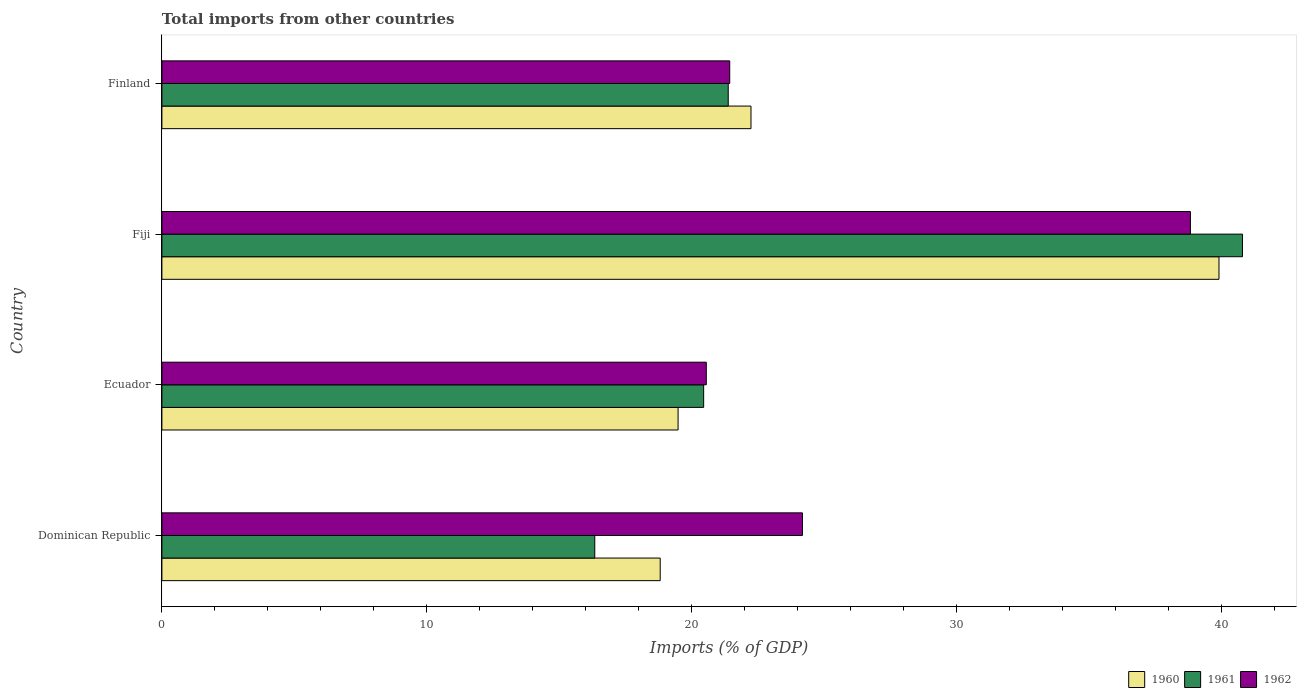How many different coloured bars are there?
Offer a very short reply. 3. How many bars are there on the 2nd tick from the top?
Your answer should be very brief. 3. What is the label of the 2nd group of bars from the top?
Your answer should be compact. Fiji. In how many cases, is the number of bars for a given country not equal to the number of legend labels?
Keep it short and to the point. 0. What is the total imports in 1961 in Ecuador?
Keep it short and to the point. 20.45. Across all countries, what is the maximum total imports in 1960?
Your answer should be very brief. 39.91. Across all countries, what is the minimum total imports in 1961?
Offer a very short reply. 16.34. In which country was the total imports in 1962 maximum?
Your answer should be compact. Fiji. In which country was the total imports in 1962 minimum?
Give a very brief answer. Ecuador. What is the total total imports in 1961 in the graph?
Provide a succinct answer. 98.98. What is the difference between the total imports in 1962 in Dominican Republic and that in Ecuador?
Offer a very short reply. 3.63. What is the difference between the total imports in 1962 in Finland and the total imports in 1961 in Dominican Republic?
Keep it short and to the point. 5.09. What is the average total imports in 1962 per country?
Your answer should be very brief. 26.25. What is the difference between the total imports in 1960 and total imports in 1962 in Fiji?
Your response must be concise. 1.08. In how many countries, is the total imports in 1961 greater than 8 %?
Provide a short and direct response. 4. What is the ratio of the total imports in 1961 in Ecuador to that in Finland?
Provide a succinct answer. 0.96. What is the difference between the highest and the second highest total imports in 1960?
Provide a short and direct response. 17.67. What is the difference between the highest and the lowest total imports in 1961?
Keep it short and to the point. 24.45. In how many countries, is the total imports in 1961 greater than the average total imports in 1961 taken over all countries?
Provide a succinct answer. 1. What does the 1st bar from the bottom in Ecuador represents?
Offer a terse response. 1960. Are the values on the major ticks of X-axis written in scientific E-notation?
Keep it short and to the point. No. Does the graph contain any zero values?
Make the answer very short. No. Does the graph contain grids?
Your answer should be compact. No. How many legend labels are there?
Offer a very short reply. 3. What is the title of the graph?
Keep it short and to the point. Total imports from other countries. Does "1960" appear as one of the legend labels in the graph?
Provide a short and direct response. Yes. What is the label or title of the X-axis?
Make the answer very short. Imports (% of GDP). What is the Imports (% of GDP) of 1960 in Dominican Republic?
Provide a short and direct response. 18.81. What is the Imports (% of GDP) of 1961 in Dominican Republic?
Offer a terse response. 16.34. What is the Imports (% of GDP) in 1962 in Dominican Republic?
Your answer should be very brief. 24.18. What is the Imports (% of GDP) of 1960 in Ecuador?
Provide a short and direct response. 19.49. What is the Imports (% of GDP) of 1961 in Ecuador?
Provide a succinct answer. 20.45. What is the Imports (% of GDP) in 1962 in Ecuador?
Provide a short and direct response. 20.55. What is the Imports (% of GDP) in 1960 in Fiji?
Offer a terse response. 39.91. What is the Imports (% of GDP) of 1961 in Fiji?
Provide a short and direct response. 40.8. What is the Imports (% of GDP) in 1962 in Fiji?
Provide a succinct answer. 38.83. What is the Imports (% of GDP) of 1960 in Finland?
Your response must be concise. 22.24. What is the Imports (% of GDP) of 1961 in Finland?
Keep it short and to the point. 21.38. What is the Imports (% of GDP) in 1962 in Finland?
Keep it short and to the point. 21.44. Across all countries, what is the maximum Imports (% of GDP) in 1960?
Offer a terse response. 39.91. Across all countries, what is the maximum Imports (% of GDP) of 1961?
Your answer should be compact. 40.8. Across all countries, what is the maximum Imports (% of GDP) of 1962?
Your response must be concise. 38.83. Across all countries, what is the minimum Imports (% of GDP) in 1960?
Ensure brevity in your answer.  18.81. Across all countries, what is the minimum Imports (% of GDP) in 1961?
Your answer should be compact. 16.34. Across all countries, what is the minimum Imports (% of GDP) in 1962?
Provide a succinct answer. 20.55. What is the total Imports (% of GDP) of 1960 in the graph?
Give a very brief answer. 100.45. What is the total Imports (% of GDP) of 1961 in the graph?
Ensure brevity in your answer.  98.98. What is the total Imports (% of GDP) in 1962 in the graph?
Offer a very short reply. 105.01. What is the difference between the Imports (% of GDP) of 1960 in Dominican Republic and that in Ecuador?
Give a very brief answer. -0.68. What is the difference between the Imports (% of GDP) of 1961 in Dominican Republic and that in Ecuador?
Your answer should be compact. -4.11. What is the difference between the Imports (% of GDP) in 1962 in Dominican Republic and that in Ecuador?
Ensure brevity in your answer.  3.63. What is the difference between the Imports (% of GDP) of 1960 in Dominican Republic and that in Fiji?
Offer a very short reply. -21.1. What is the difference between the Imports (% of GDP) of 1961 in Dominican Republic and that in Fiji?
Give a very brief answer. -24.45. What is the difference between the Imports (% of GDP) of 1962 in Dominican Republic and that in Fiji?
Your response must be concise. -14.65. What is the difference between the Imports (% of GDP) of 1960 in Dominican Republic and that in Finland?
Make the answer very short. -3.43. What is the difference between the Imports (% of GDP) of 1961 in Dominican Republic and that in Finland?
Your response must be concise. -5.04. What is the difference between the Imports (% of GDP) in 1962 in Dominican Republic and that in Finland?
Offer a terse response. 2.75. What is the difference between the Imports (% of GDP) of 1960 in Ecuador and that in Fiji?
Provide a succinct answer. -20.42. What is the difference between the Imports (% of GDP) of 1961 in Ecuador and that in Fiji?
Your answer should be very brief. -20.34. What is the difference between the Imports (% of GDP) of 1962 in Ecuador and that in Fiji?
Ensure brevity in your answer.  -18.28. What is the difference between the Imports (% of GDP) in 1960 in Ecuador and that in Finland?
Provide a succinct answer. -2.75. What is the difference between the Imports (% of GDP) of 1961 in Ecuador and that in Finland?
Provide a succinct answer. -0.93. What is the difference between the Imports (% of GDP) in 1962 in Ecuador and that in Finland?
Ensure brevity in your answer.  -0.88. What is the difference between the Imports (% of GDP) of 1960 in Fiji and that in Finland?
Your answer should be compact. 17.67. What is the difference between the Imports (% of GDP) of 1961 in Fiji and that in Finland?
Give a very brief answer. 19.41. What is the difference between the Imports (% of GDP) of 1962 in Fiji and that in Finland?
Give a very brief answer. 17.39. What is the difference between the Imports (% of GDP) of 1960 in Dominican Republic and the Imports (% of GDP) of 1961 in Ecuador?
Make the answer very short. -1.64. What is the difference between the Imports (% of GDP) in 1960 in Dominican Republic and the Imports (% of GDP) in 1962 in Ecuador?
Give a very brief answer. -1.74. What is the difference between the Imports (% of GDP) in 1961 in Dominican Republic and the Imports (% of GDP) in 1962 in Ecuador?
Offer a very short reply. -4.21. What is the difference between the Imports (% of GDP) of 1960 in Dominican Republic and the Imports (% of GDP) of 1961 in Fiji?
Offer a very short reply. -21.98. What is the difference between the Imports (% of GDP) in 1960 in Dominican Republic and the Imports (% of GDP) in 1962 in Fiji?
Your response must be concise. -20.02. What is the difference between the Imports (% of GDP) in 1961 in Dominican Republic and the Imports (% of GDP) in 1962 in Fiji?
Your answer should be very brief. -22.49. What is the difference between the Imports (% of GDP) of 1960 in Dominican Republic and the Imports (% of GDP) of 1961 in Finland?
Provide a succinct answer. -2.57. What is the difference between the Imports (% of GDP) of 1960 in Dominican Republic and the Imports (% of GDP) of 1962 in Finland?
Your response must be concise. -2.62. What is the difference between the Imports (% of GDP) of 1961 in Dominican Republic and the Imports (% of GDP) of 1962 in Finland?
Ensure brevity in your answer.  -5.09. What is the difference between the Imports (% of GDP) in 1960 in Ecuador and the Imports (% of GDP) in 1961 in Fiji?
Offer a terse response. -21.31. What is the difference between the Imports (% of GDP) of 1960 in Ecuador and the Imports (% of GDP) of 1962 in Fiji?
Ensure brevity in your answer.  -19.34. What is the difference between the Imports (% of GDP) of 1961 in Ecuador and the Imports (% of GDP) of 1962 in Fiji?
Provide a short and direct response. -18.38. What is the difference between the Imports (% of GDP) of 1960 in Ecuador and the Imports (% of GDP) of 1961 in Finland?
Make the answer very short. -1.89. What is the difference between the Imports (% of GDP) of 1960 in Ecuador and the Imports (% of GDP) of 1962 in Finland?
Your answer should be very brief. -1.95. What is the difference between the Imports (% of GDP) of 1961 in Ecuador and the Imports (% of GDP) of 1962 in Finland?
Offer a very short reply. -0.98. What is the difference between the Imports (% of GDP) of 1960 in Fiji and the Imports (% of GDP) of 1961 in Finland?
Give a very brief answer. 18.53. What is the difference between the Imports (% of GDP) in 1960 in Fiji and the Imports (% of GDP) in 1962 in Finland?
Provide a succinct answer. 18.47. What is the difference between the Imports (% of GDP) in 1961 in Fiji and the Imports (% of GDP) in 1962 in Finland?
Provide a short and direct response. 19.36. What is the average Imports (% of GDP) in 1960 per country?
Your response must be concise. 25.11. What is the average Imports (% of GDP) of 1961 per country?
Make the answer very short. 24.74. What is the average Imports (% of GDP) in 1962 per country?
Provide a succinct answer. 26.25. What is the difference between the Imports (% of GDP) in 1960 and Imports (% of GDP) in 1961 in Dominican Republic?
Give a very brief answer. 2.47. What is the difference between the Imports (% of GDP) in 1960 and Imports (% of GDP) in 1962 in Dominican Republic?
Make the answer very short. -5.37. What is the difference between the Imports (% of GDP) of 1961 and Imports (% of GDP) of 1962 in Dominican Republic?
Make the answer very short. -7.84. What is the difference between the Imports (% of GDP) of 1960 and Imports (% of GDP) of 1961 in Ecuador?
Offer a very short reply. -0.97. What is the difference between the Imports (% of GDP) in 1960 and Imports (% of GDP) in 1962 in Ecuador?
Offer a terse response. -1.07. What is the difference between the Imports (% of GDP) in 1961 and Imports (% of GDP) in 1962 in Ecuador?
Offer a very short reply. -0.1. What is the difference between the Imports (% of GDP) in 1960 and Imports (% of GDP) in 1961 in Fiji?
Offer a very short reply. -0.89. What is the difference between the Imports (% of GDP) of 1960 and Imports (% of GDP) of 1962 in Fiji?
Your answer should be compact. 1.08. What is the difference between the Imports (% of GDP) in 1961 and Imports (% of GDP) in 1962 in Fiji?
Make the answer very short. 1.96. What is the difference between the Imports (% of GDP) of 1960 and Imports (% of GDP) of 1961 in Finland?
Ensure brevity in your answer.  0.86. What is the difference between the Imports (% of GDP) in 1960 and Imports (% of GDP) in 1962 in Finland?
Your response must be concise. 0.8. What is the difference between the Imports (% of GDP) of 1961 and Imports (% of GDP) of 1962 in Finland?
Provide a succinct answer. -0.06. What is the ratio of the Imports (% of GDP) of 1960 in Dominican Republic to that in Ecuador?
Your answer should be very brief. 0.97. What is the ratio of the Imports (% of GDP) in 1961 in Dominican Republic to that in Ecuador?
Provide a short and direct response. 0.8. What is the ratio of the Imports (% of GDP) in 1962 in Dominican Republic to that in Ecuador?
Your response must be concise. 1.18. What is the ratio of the Imports (% of GDP) of 1960 in Dominican Republic to that in Fiji?
Keep it short and to the point. 0.47. What is the ratio of the Imports (% of GDP) in 1961 in Dominican Republic to that in Fiji?
Your answer should be very brief. 0.4. What is the ratio of the Imports (% of GDP) of 1962 in Dominican Republic to that in Fiji?
Give a very brief answer. 0.62. What is the ratio of the Imports (% of GDP) of 1960 in Dominican Republic to that in Finland?
Offer a very short reply. 0.85. What is the ratio of the Imports (% of GDP) of 1961 in Dominican Republic to that in Finland?
Offer a terse response. 0.76. What is the ratio of the Imports (% of GDP) of 1962 in Dominican Republic to that in Finland?
Offer a terse response. 1.13. What is the ratio of the Imports (% of GDP) of 1960 in Ecuador to that in Fiji?
Your response must be concise. 0.49. What is the ratio of the Imports (% of GDP) of 1961 in Ecuador to that in Fiji?
Provide a succinct answer. 0.5. What is the ratio of the Imports (% of GDP) in 1962 in Ecuador to that in Fiji?
Your response must be concise. 0.53. What is the ratio of the Imports (% of GDP) of 1960 in Ecuador to that in Finland?
Ensure brevity in your answer.  0.88. What is the ratio of the Imports (% of GDP) in 1961 in Ecuador to that in Finland?
Your response must be concise. 0.96. What is the ratio of the Imports (% of GDP) of 1962 in Ecuador to that in Finland?
Provide a short and direct response. 0.96. What is the ratio of the Imports (% of GDP) in 1960 in Fiji to that in Finland?
Make the answer very short. 1.79. What is the ratio of the Imports (% of GDP) of 1961 in Fiji to that in Finland?
Give a very brief answer. 1.91. What is the ratio of the Imports (% of GDP) in 1962 in Fiji to that in Finland?
Offer a terse response. 1.81. What is the difference between the highest and the second highest Imports (% of GDP) of 1960?
Offer a terse response. 17.67. What is the difference between the highest and the second highest Imports (% of GDP) of 1961?
Make the answer very short. 19.41. What is the difference between the highest and the second highest Imports (% of GDP) in 1962?
Offer a very short reply. 14.65. What is the difference between the highest and the lowest Imports (% of GDP) of 1960?
Offer a terse response. 21.1. What is the difference between the highest and the lowest Imports (% of GDP) in 1961?
Provide a succinct answer. 24.45. What is the difference between the highest and the lowest Imports (% of GDP) of 1962?
Ensure brevity in your answer.  18.28. 